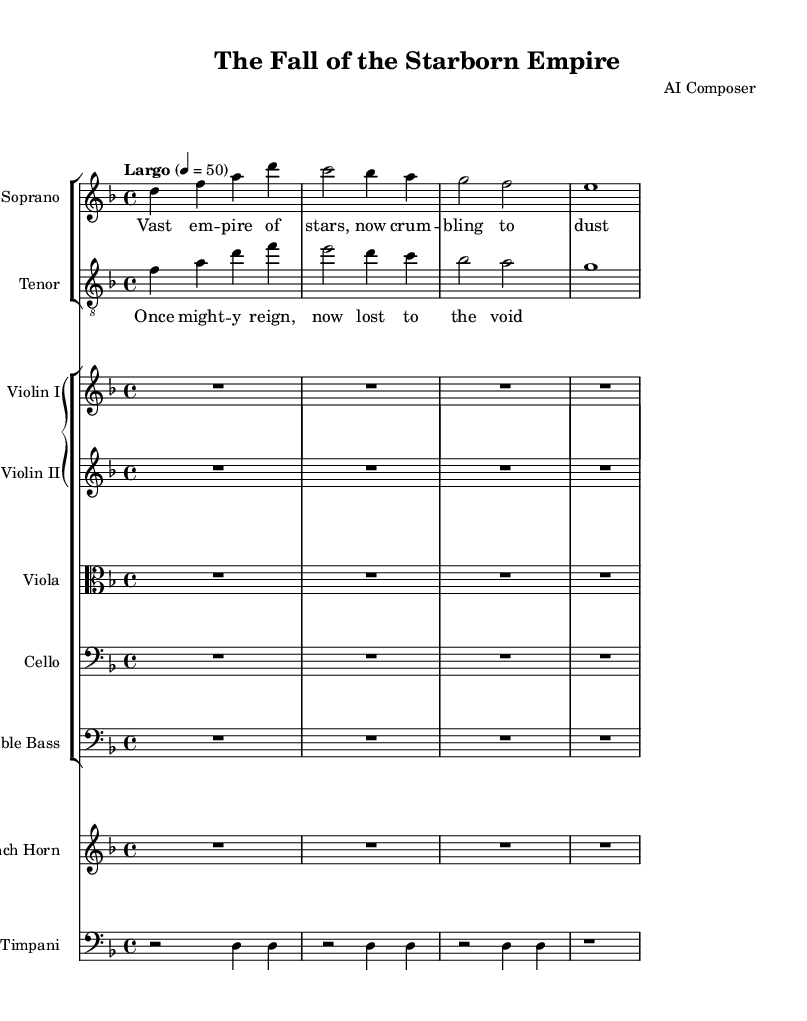What is the key signature of this music? The key signature is indicated at the beginning of the staff, featuring one flat, which defines D minor.
Answer: D minor What is the time signature of this music? The time signature is represented by the number at the beginning of the piece, which shows 4 beats in a measure.
Answer: 4/4 What is the tempo marking for this piece? The tempo marking is located above the staff and indicates a "Largo" tempo at a speed of 50 beats per minute.
Answer: Largo, 50 How many measures are in the given soprano line? Counting each vertical line in the soprano staff indicates four measures in total.
Answer: 4 What is the primary lyric theme presented in the soprano part? The title of the lyric in the soprano part suggests the theme of a mighty empire collapsing, as indicated by the words "Vast empire of stars, now crumbling to dust."
Answer: Crumbling empire Which instruments are included in the string section? Looking at the ensemble layout, the instruments specified in the string section are Violin I, Violin II, Viola, Cello, and Double Bass.
Answer: Violin I, Violin II, Viola, Cello, Double Bass What role does the timpani play in this piece? The presence of the timpani in the score alongside rhythmic notations indicates its role is likely to provide dramatic emphasis and accent in the orchestration.
Answer: Dramatic emphasis 